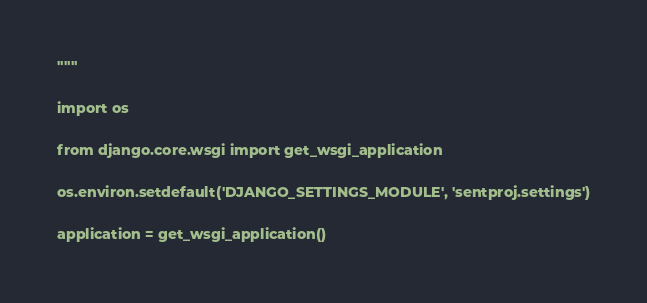Convert code to text. <code><loc_0><loc_0><loc_500><loc_500><_Python_>"""

import os

from django.core.wsgi import get_wsgi_application

os.environ.setdefault('DJANGO_SETTINGS_MODULE', 'sentproj.settings')

application = get_wsgi_application()
</code> 